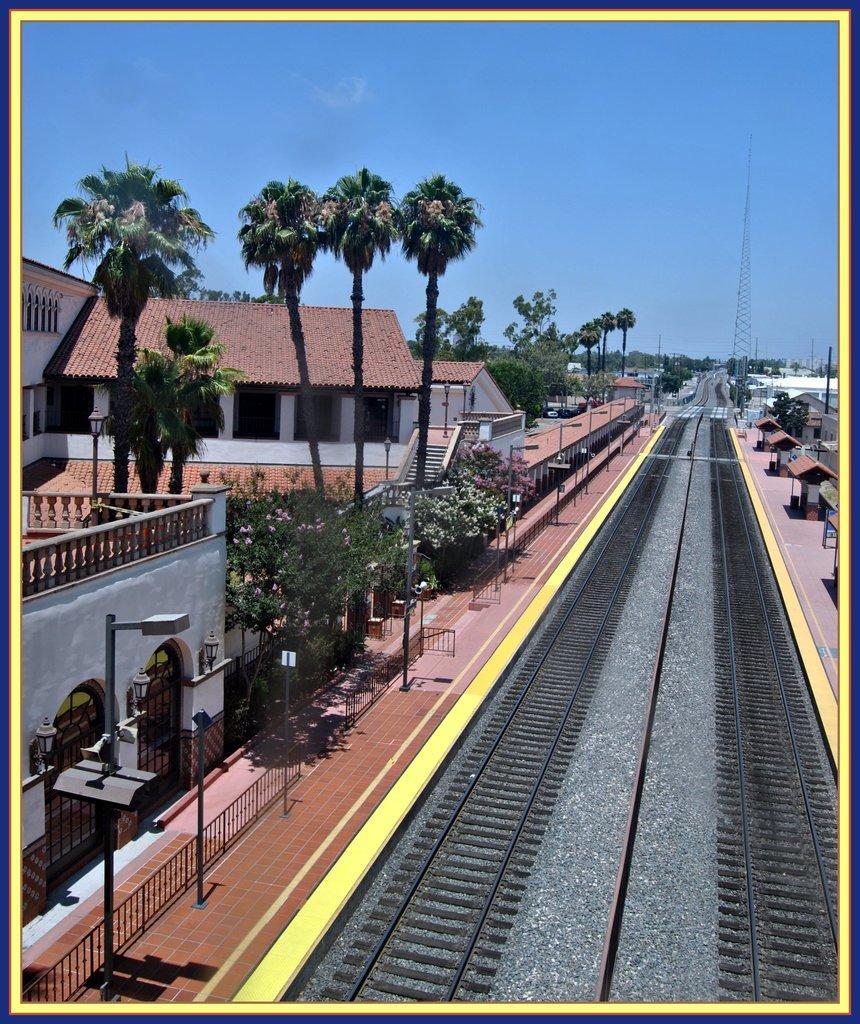Describe this image in one or two sentences. In the foreground of this image, there are railway tracks to which trees, poles, shed, platform are on the either side. In the background, there are buildings, trees, a tower and the sky. 